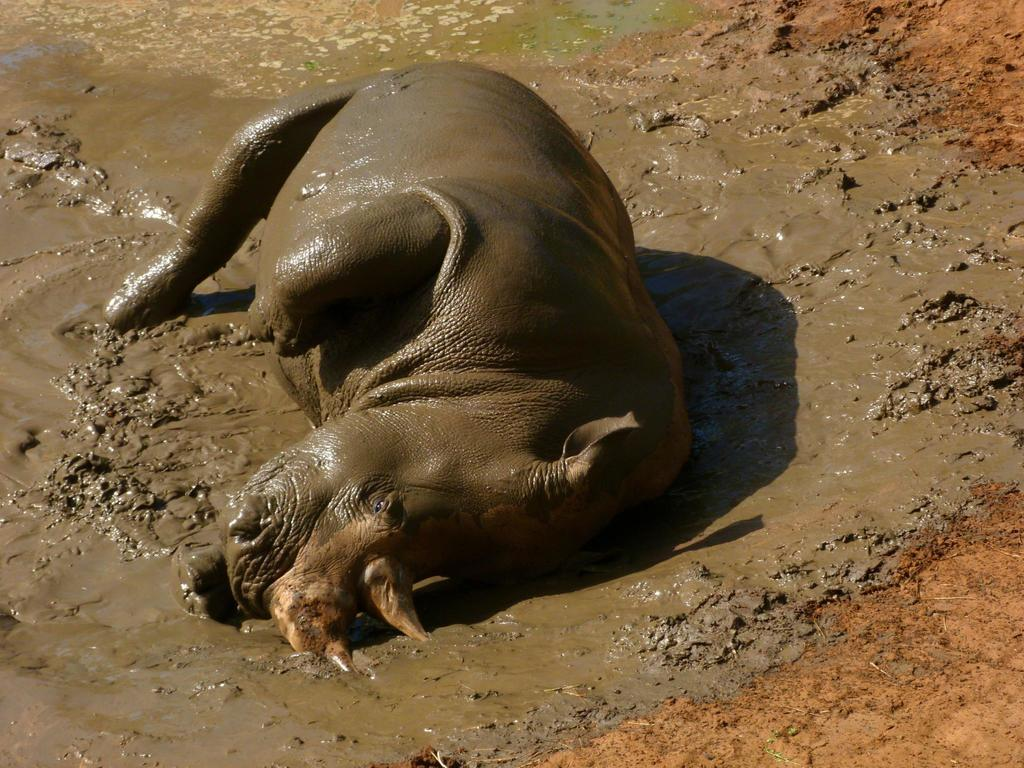What animal is the main subject of the image? There is a hippopotamus in the image. What is the hippopotamus doing in the image? The hippopotamus is lying in the mud water. What type of comb is the hippopotamus using in the image? There is no comb present in the image, as the hippopotamus is lying in the mud water. 